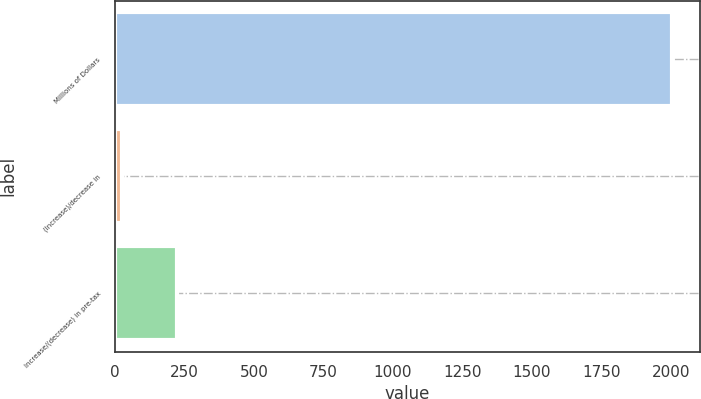<chart> <loc_0><loc_0><loc_500><loc_500><bar_chart><fcel>Millions of Dollars<fcel>(Increase)/decrease in<fcel>Increase/(decrease) in pre-tax<nl><fcel>2004<fcel>24<fcel>222<nl></chart> 